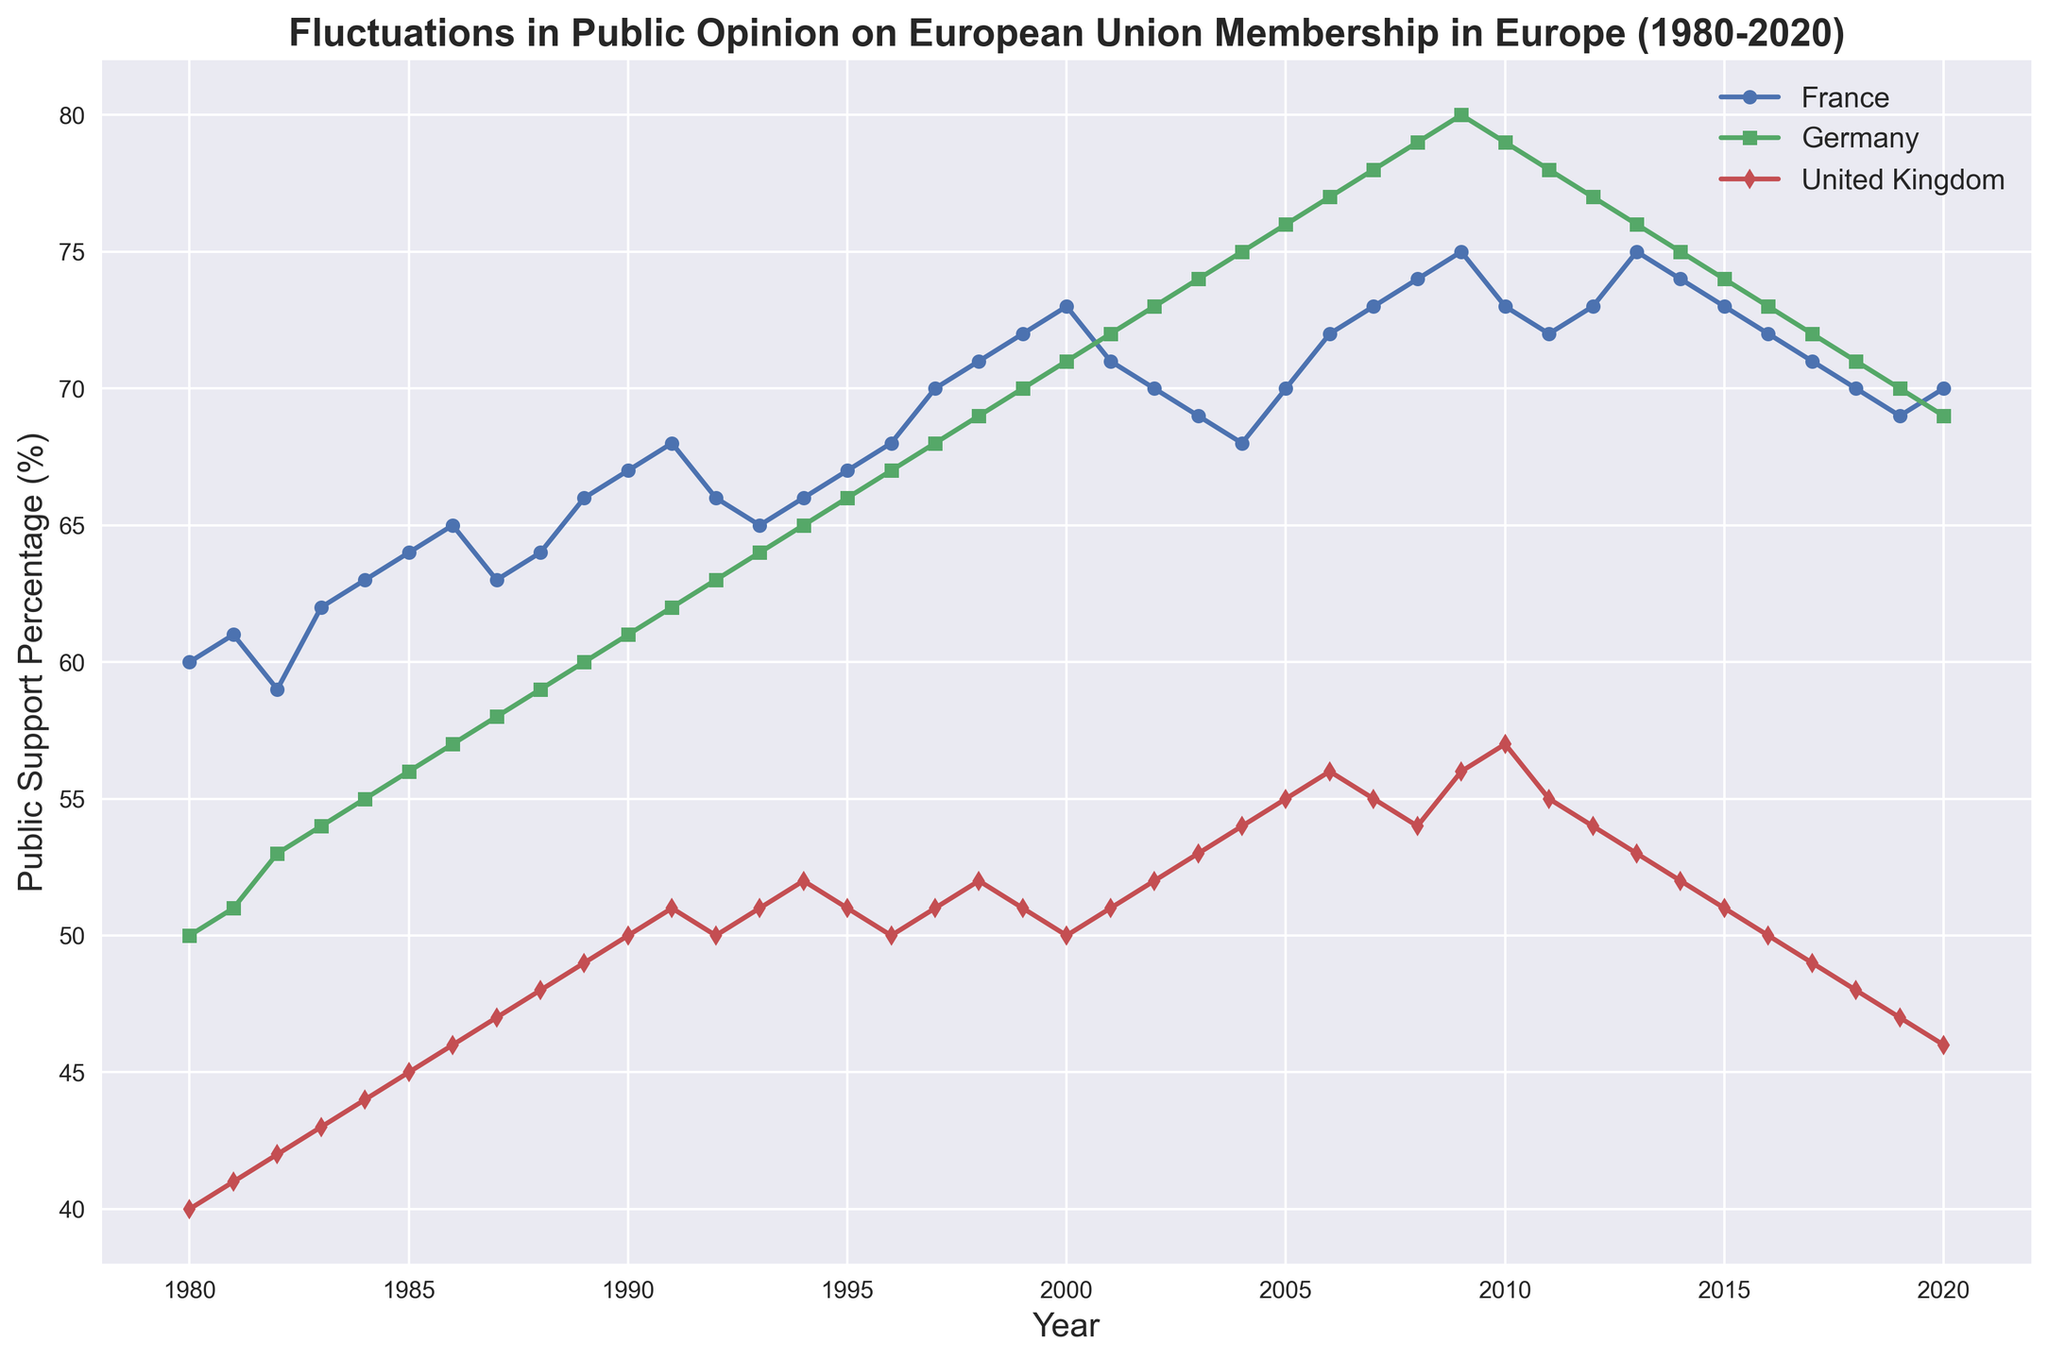Which country had the highest public support for European Union Membership in 2020? Observe the endpoints of the lines on the plot. In 2020, Germany had the highest public support at 69%, followed by France at 70%, and the United Kingdom had the lowest with 46%.
Answer: Germany Between which years did France see the most significant increase in public support for European Union Membership? Look for the steepest upward slope in France's line. The steepest increase occurs between 1996 and 1997 when the support jumped from 68% to 70%.
Answer: 1996 to 1997 How does the maximum public support percentage for European Union Membership in France compare to Germany? Observe the highest points on each line. France’s maximum public support was 75%, Germany’s was 80%. Therefore, Germany’s highest support was higher.
Answer: Germany's highest support percentage is greater What is the average public support for European Union Membership in the United Kingdom from 2000 to 2020? Sum the percentages from 2000 to 2020 and divide by the number of years (21). The percentages are: 50, 51, 52, 53, 54, 55, 56, 55, 54, 56, 57, 55, 54, 53, 52, 51, 50, 49, 48, 47, 46, making the sum 1093, and the average 1093/21 ≈ 52.05.
Answer: 52.05 During which decade did the United Kingdom experience the most significant decline in support for European Union Membership? Observe the slope of the United Kingdom’s line for each decade. The most significant decline occurs in the 2010s, where it dropped from 57% in 2010 to 46% in 2020.
Answer: 2010s When did Germany first surpass 70% public support for European Union Membership, and how long did it remain above 70% consecutively? Find the year when Germany's line crosses the 70% mark. It first surpassed 70% in 1999 and remained above 70% until 2020, which is 22 years consecutively.
Answer: 1999, 22 years What is the trend in public support for European Union Membership in France from 1980 to 2020? Follow France's line from 1980 to 2020. The trend shows a gradual increase, peaking in 2009 at 75%, with a slight decrease towards the end, reaching 70% in 2020.
Answer: Gradually increasing with a peak around 2009, slight decrease towards 2020 Which country had the lowest starting point for public support of European Union Membership in 1980, and what was the percentage? Check the starting points of the lines in 1980. The United Kingdom had the lowest starting point at 40%.
Answer: The United Kingdom, 40% How did the public support in Germany compare to France in the year 2000? Locate the data points for Germany and France in 2000. France had 73% support, whereas Germany had 71% support.
Answer: France had higher support Summarize the overall trend in public opinion on European Union Membership in the United Kingdom from 1980 to 2020. Follow the United Kingdom's line from 1980 to 2020. Starting at 40% in 1980, it gradually increased to a peak of 57% in 2010 but then declined to 46% by 2020, indicating an initial rise followed by a decline.
Answer: Initial rise, followed by a decline 